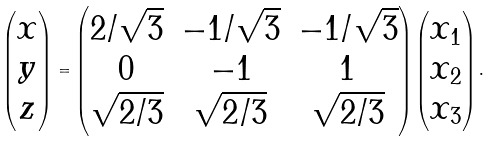Convert formula to latex. <formula><loc_0><loc_0><loc_500><loc_500>\begin{pmatrix} { x } \\ { y } \\ { z } \end{pmatrix} = \begin{pmatrix} 2 / \sqrt { 3 } & - 1 / \sqrt { 3 } & - 1 / \sqrt { 3 } \\ 0 & - 1 & 1 \\ \sqrt { 2 / 3 } & \sqrt { 2 / 3 } & \sqrt { 2 / 3 } \end{pmatrix} \begin{pmatrix} { x } _ { 1 } \\ { x } _ { 2 } \\ { x } _ { 3 } \end{pmatrix} .</formula> 